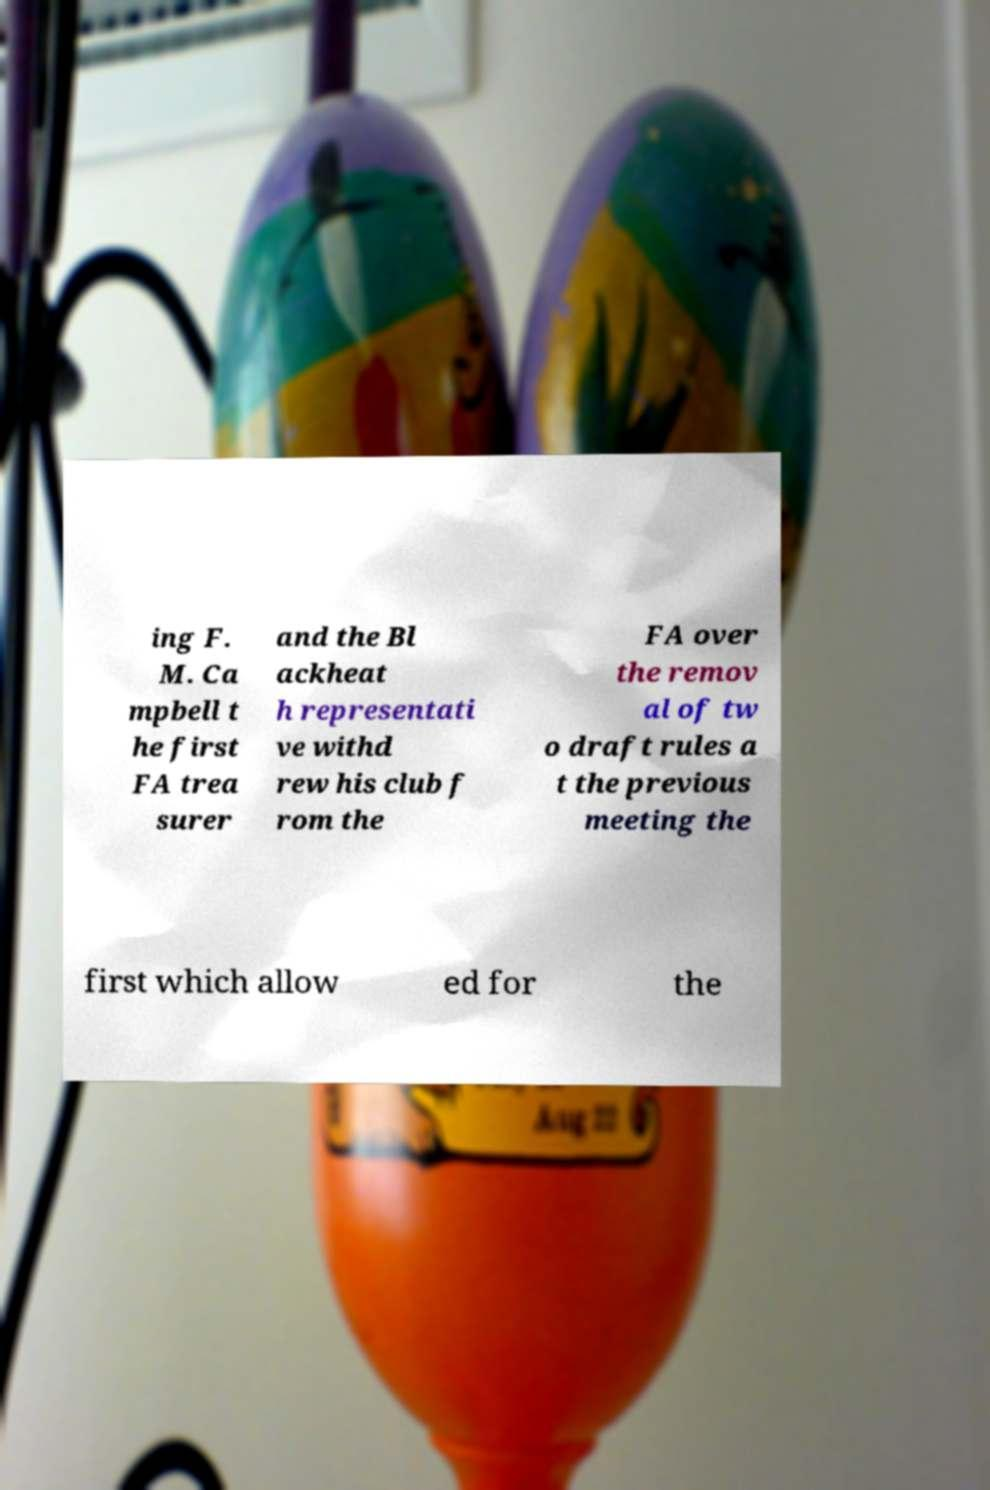I need the written content from this picture converted into text. Can you do that? ing F. M. Ca mpbell t he first FA trea surer and the Bl ackheat h representati ve withd rew his club f rom the FA over the remov al of tw o draft rules a t the previous meeting the first which allow ed for the 